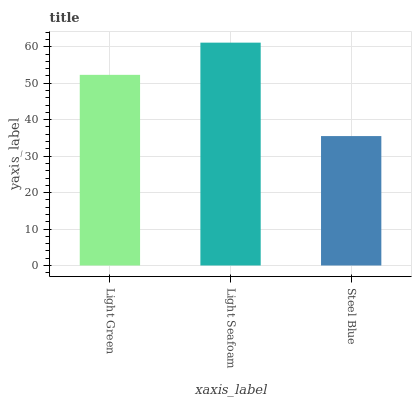Is Steel Blue the minimum?
Answer yes or no. Yes. Is Light Seafoam the maximum?
Answer yes or no. Yes. Is Light Seafoam the minimum?
Answer yes or no. No. Is Steel Blue the maximum?
Answer yes or no. No. Is Light Seafoam greater than Steel Blue?
Answer yes or no. Yes. Is Steel Blue less than Light Seafoam?
Answer yes or no. Yes. Is Steel Blue greater than Light Seafoam?
Answer yes or no. No. Is Light Seafoam less than Steel Blue?
Answer yes or no. No. Is Light Green the high median?
Answer yes or no. Yes. Is Light Green the low median?
Answer yes or no. Yes. Is Light Seafoam the high median?
Answer yes or no. No. Is Light Seafoam the low median?
Answer yes or no. No. 